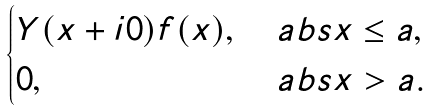Convert formula to latex. <formula><loc_0><loc_0><loc_500><loc_500>\begin{cases} Y ( x + i 0 ) f ( x ) , & \ a b s { x } \leq a , \\ 0 , & \ a b s { x } > a . \end{cases}</formula> 